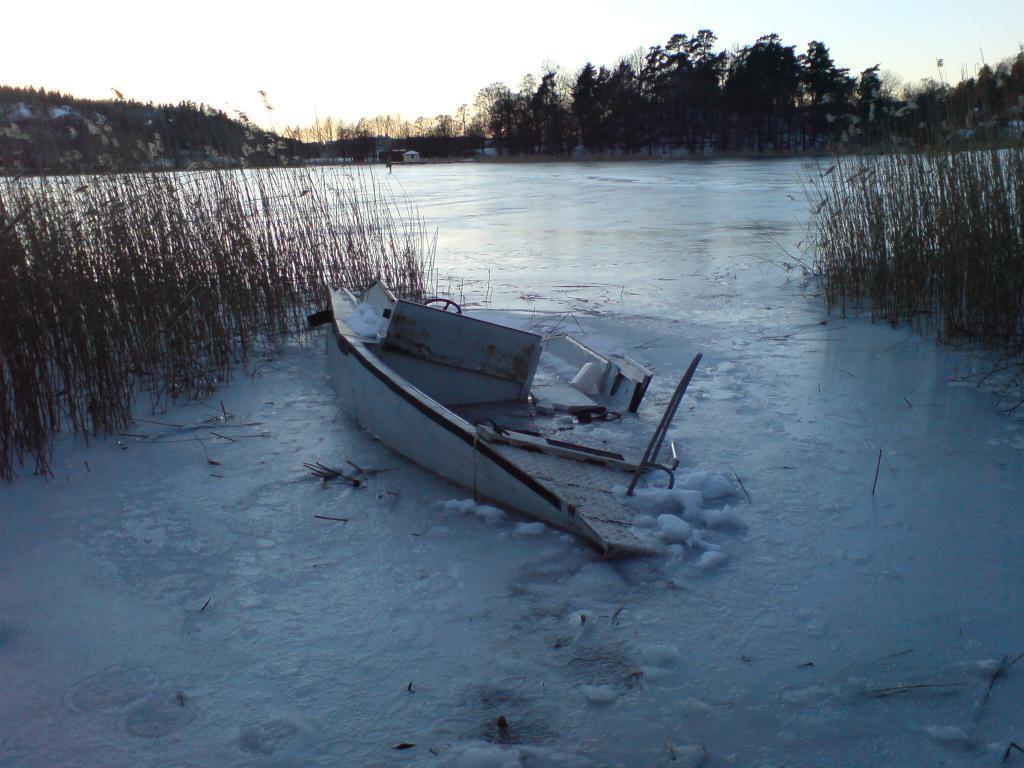How would you summarize this image in a sentence or two? In this picture we can see a boat, there is Ice, there are some plants and in the background of the picture there are some trees, houses and top of the picture there is clear sky. 